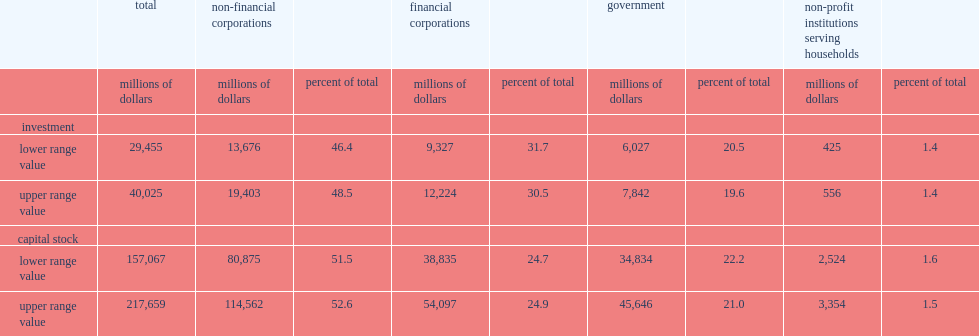What are the percentages of non-financial corporations sector accounting for the investment and stock respectively? 46.4 51.5. What are the percentages of government sector accounting for the investment and stock respectively? 20.5 22.2. 